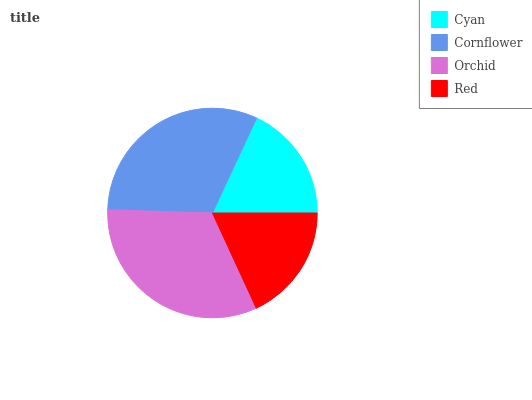Is Cyan the minimum?
Answer yes or no. Yes. Is Orchid the maximum?
Answer yes or no. Yes. Is Cornflower the minimum?
Answer yes or no. No. Is Cornflower the maximum?
Answer yes or no. No. Is Cornflower greater than Cyan?
Answer yes or no. Yes. Is Cyan less than Cornflower?
Answer yes or no. Yes. Is Cyan greater than Cornflower?
Answer yes or no. No. Is Cornflower less than Cyan?
Answer yes or no. No. Is Cornflower the high median?
Answer yes or no. Yes. Is Red the low median?
Answer yes or no. Yes. Is Cyan the high median?
Answer yes or no. No. Is Orchid the low median?
Answer yes or no. No. 